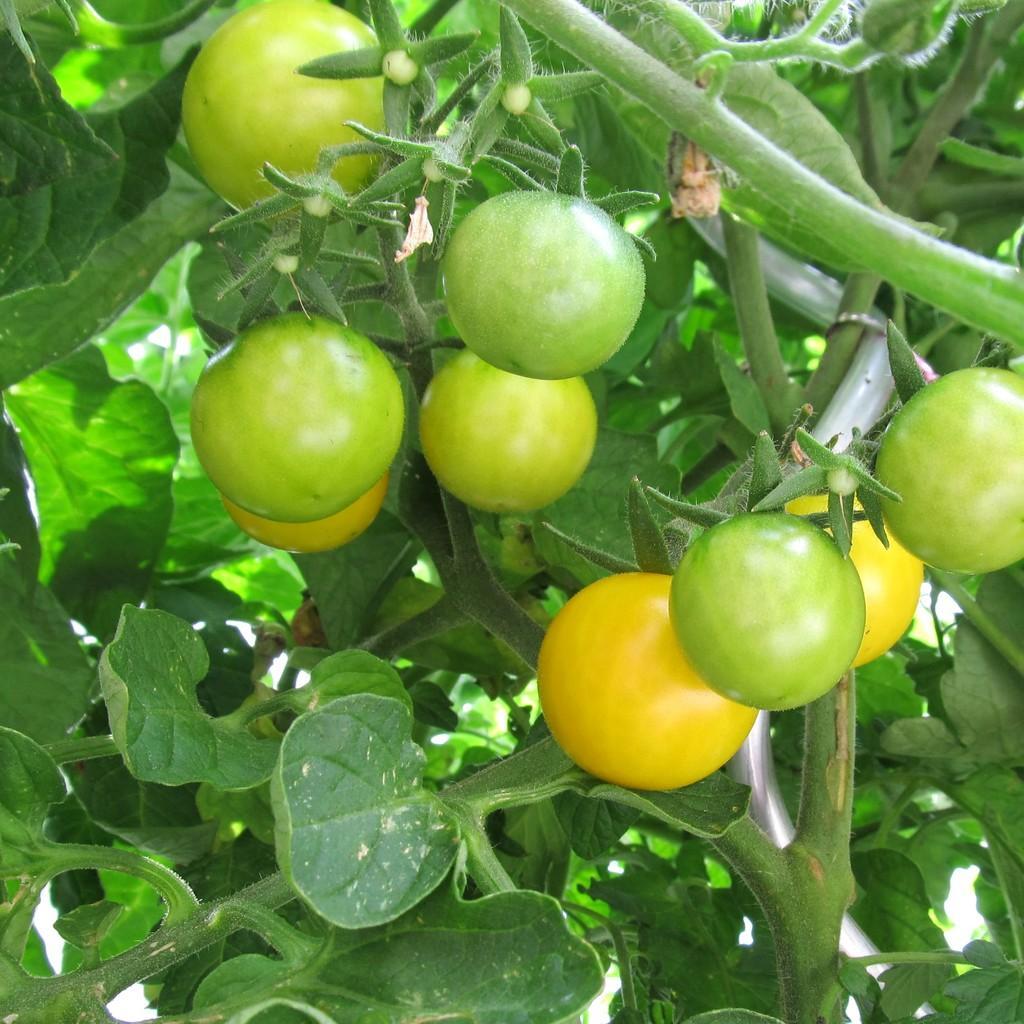Can you describe this image briefly? In the picture I can see planets which has vegetables. This vegetables are green and yellow in color. 